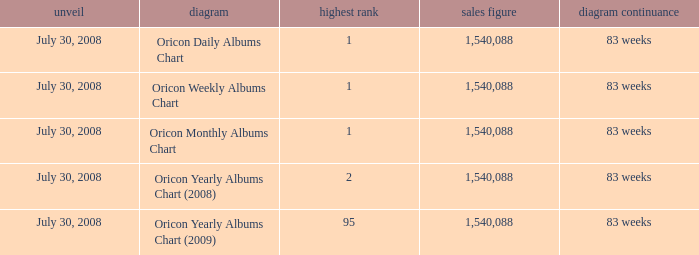Which Chart has a Peak Position of 1? Oricon Daily Albums Chart, Oricon Weekly Albums Chart, Oricon Monthly Albums Chart. 